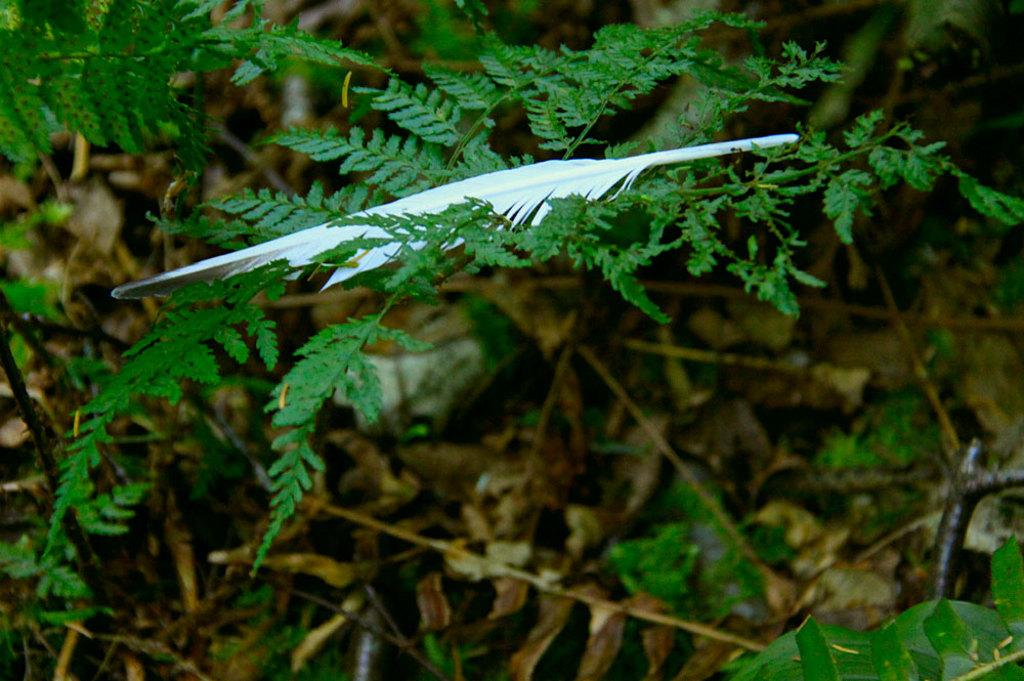What object can be seen in the image? There is a feather in the image. Where is the feather located? The feather is on a plant. What colors are present on the feather? The feather has white and black colors. What can be found at the bottom of the image? There are dried leaves at the bottom of the image. Is there a wheel visible in the image? No, there is no wheel present in the image. Can you see any cracks on the feather in the image? No, there are no cracks visible on the feather in the image. 